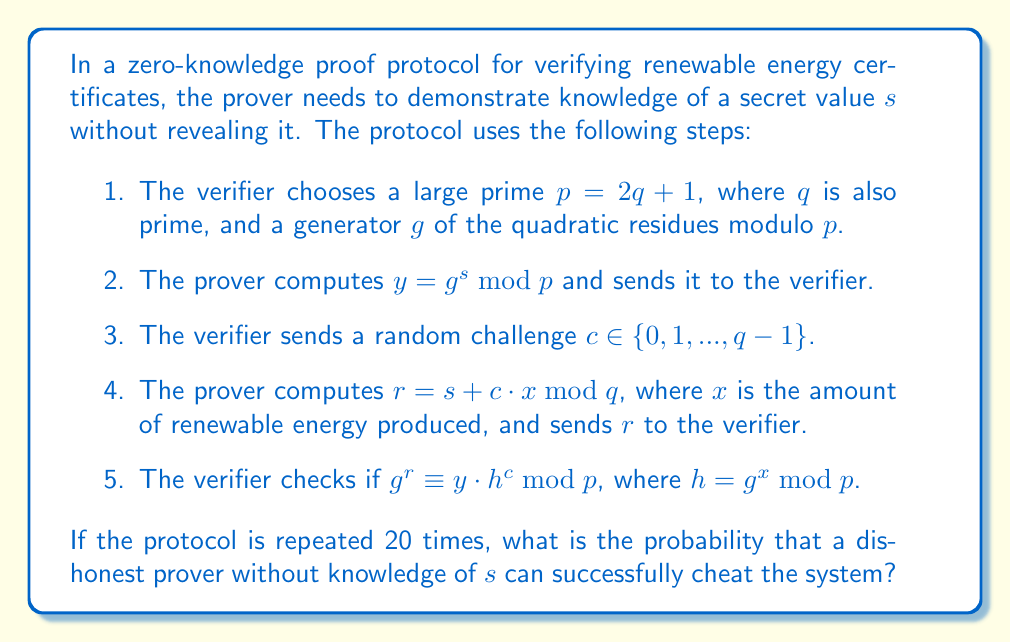Can you answer this question? To solve this problem, we need to follow these steps:

1. Understand the security of a single round:
   In each round, a dishonest prover has a 1/2 chance of guessing the correct challenge $c$. This is because there are two possible outcomes (0 or 1) for each bit of the challenge.

2. Calculate the probability of successful cheating in a single round:
   $P(\text{success in one round}) = \frac{1}{2}$

3. Calculate the probability of successful cheating in all 20 rounds:
   The prover needs to guess correctly in all 20 rounds to successfully cheat the system. This is equivalent to the probability of getting 20 successes in 20 independent trials, each with a probability of 1/2.

   $P(\text{success in all 20 rounds}) = (\frac{1}{2})^{20}$

4. Compute the final probability:
   $$P(\text{successful cheating}) = (\frac{1}{2})^{20} = \frac{1}{1,048,576} \approx 9.54 \times 10^{-7}$$

This extremely low probability demonstrates the effectiveness of the zero-knowledge proof protocol for verifying renewable energy certificates, as it makes it virtually impossible for a dishonest prover to cheat the system consistently.
Answer: $\frac{1}{1,048,576}$ or approximately $9.54 \times 10^{-7}$ 